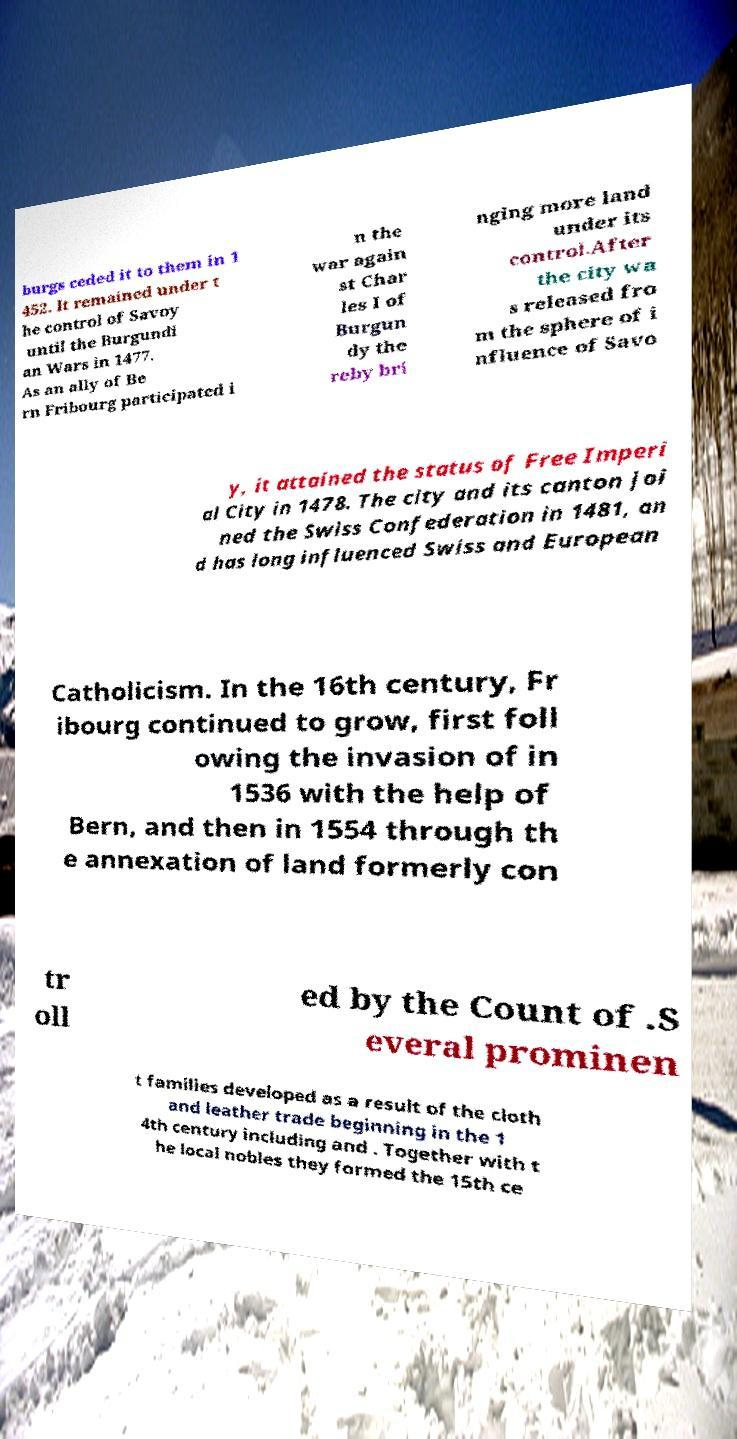I need the written content from this picture converted into text. Can you do that? burgs ceded it to them in 1 452. It remained under t he control of Savoy until the Burgundi an Wars in 1477. As an ally of Be rn Fribourg participated i n the war again st Char les I of Burgun dy the reby bri nging more land under its control.After the city wa s released fro m the sphere of i nfluence of Savo y, it attained the status of Free Imperi al City in 1478. The city and its canton joi ned the Swiss Confederation in 1481, an d has long influenced Swiss and European Catholicism. In the 16th century, Fr ibourg continued to grow, first foll owing the invasion of in 1536 with the help of Bern, and then in 1554 through th e annexation of land formerly con tr oll ed by the Count of .S everal prominen t families developed as a result of the cloth and leather trade beginning in the 1 4th century including and . Together with t he local nobles they formed the 15th ce 